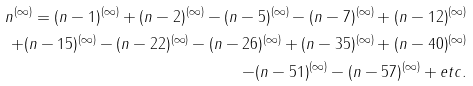<formula> <loc_0><loc_0><loc_500><loc_500>n ^ { ( \infty ) } = ( n - 1 ) ^ { ( \infty ) } + ( n - 2 ) ^ { ( \infty ) } - ( n - 5 ) ^ { ( \infty ) } - ( n - 7 ) ^ { ( \infty ) } + ( n - 1 2 ) ^ { ( \infty ) } \\ + ( n - 1 5 ) ^ { ( \infty ) } - ( n - 2 2 ) ^ { ( \infty ) } - ( n - 2 6 ) ^ { ( \infty ) } + ( n - 3 5 ) ^ { ( \infty ) } + ( n - 4 0 ) ^ { ( \infty ) } \\ - ( n - 5 1 ) ^ { ( \infty ) } - ( n - 5 7 ) ^ { ( \infty ) } + e t c .</formula> 